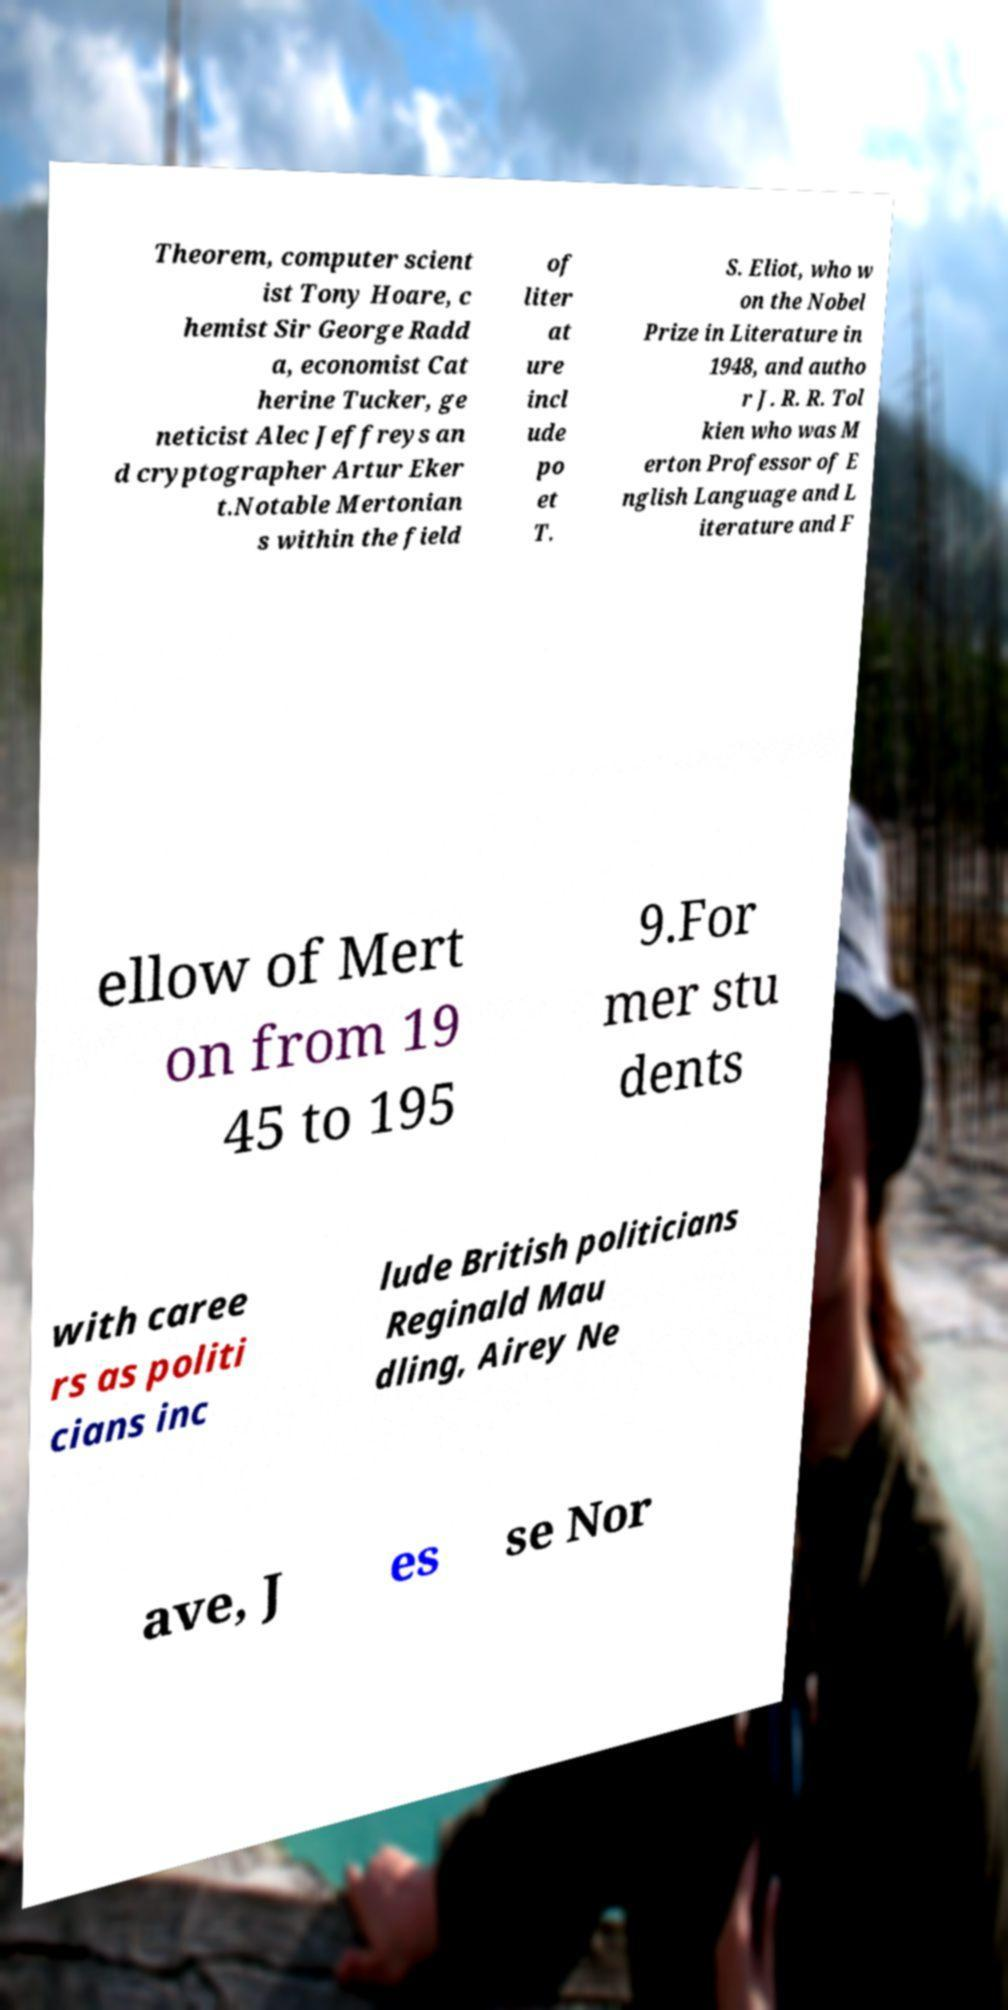Could you assist in decoding the text presented in this image and type it out clearly? Theorem, computer scient ist Tony Hoare, c hemist Sir George Radd a, economist Cat herine Tucker, ge neticist Alec Jeffreys an d cryptographer Artur Eker t.Notable Mertonian s within the field of liter at ure incl ude po et T. S. Eliot, who w on the Nobel Prize in Literature in 1948, and autho r J. R. R. Tol kien who was M erton Professor of E nglish Language and L iterature and F ellow of Mert on from 19 45 to 195 9.For mer stu dents with caree rs as politi cians inc lude British politicians Reginald Mau dling, Airey Ne ave, J es se Nor 